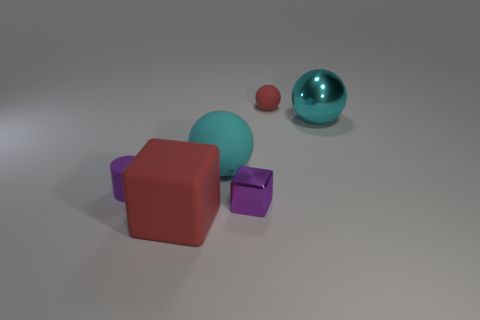There is a small red sphere behind the purple object on the right side of the matte cylinder on the left side of the red block; what is it made of?
Make the answer very short. Rubber. Are there any other metallic things of the same size as the purple metal thing?
Offer a terse response. No. What is the size of the purple cylinder that is made of the same material as the small red thing?
Your answer should be compact. Small. The purple metal object is what shape?
Your answer should be very brief. Cube. Are the large block and the tiny thing in front of the purple matte object made of the same material?
Keep it short and to the point. No. How many things are either tiny red shiny things or small purple metal objects?
Provide a short and direct response. 1. Are there any cyan things?
Give a very brief answer. Yes. What is the shape of the big thing that is in front of the tiny purple object right of the big red matte cube?
Your answer should be very brief. Cube. What number of things are either things in front of the tiny purple cylinder or cyan spheres left of the big metal ball?
Your answer should be very brief. 3. What is the material of the purple thing that is the same size as the metal block?
Ensure brevity in your answer.  Rubber. 